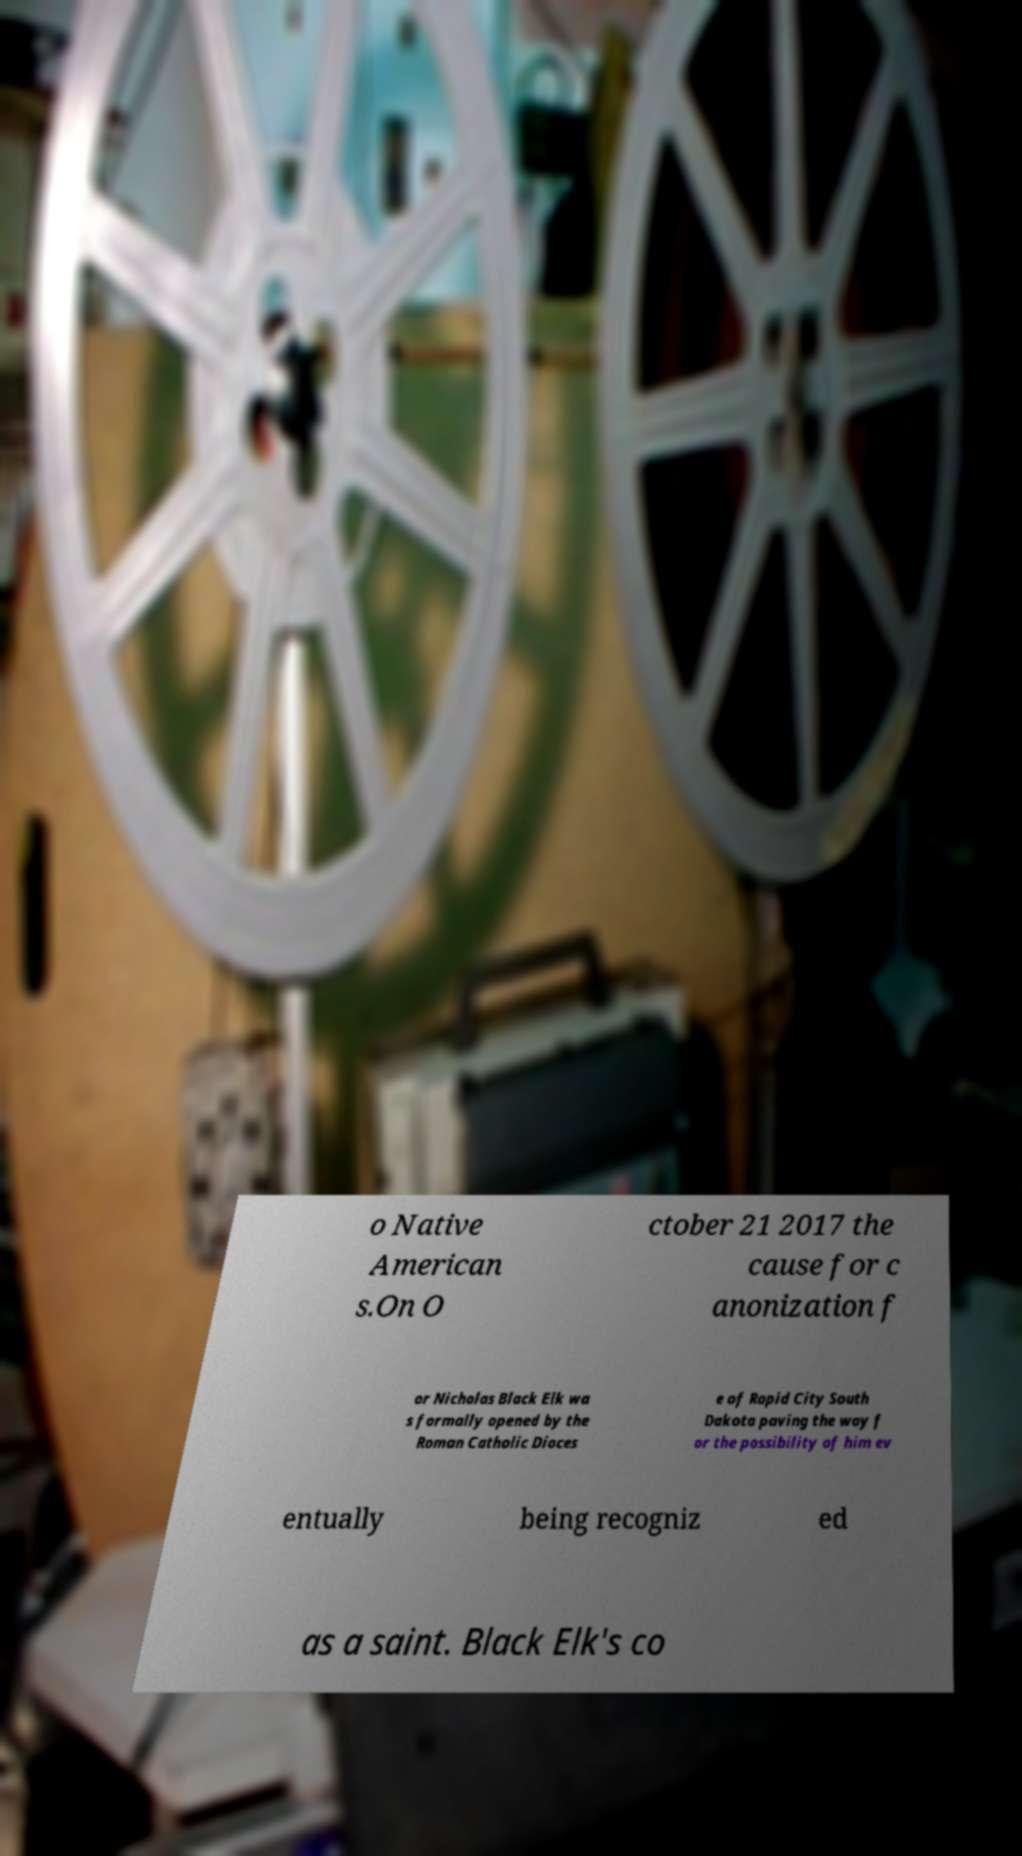Please identify and transcribe the text found in this image. o Native American s.On O ctober 21 2017 the cause for c anonization f or Nicholas Black Elk wa s formally opened by the Roman Catholic Dioces e of Rapid City South Dakota paving the way f or the possibility of him ev entually being recogniz ed as a saint. Black Elk's co 